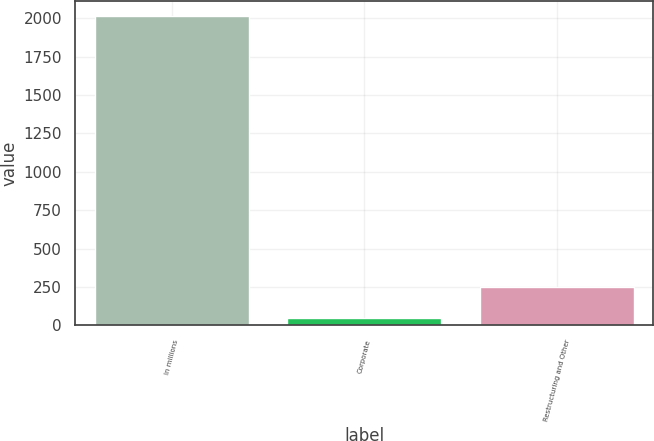<chart> <loc_0><loc_0><loc_500><loc_500><bar_chart><fcel>In millions<fcel>Corporate<fcel>Restructuring and Other<nl><fcel>2012<fcel>51<fcel>247.1<nl></chart> 